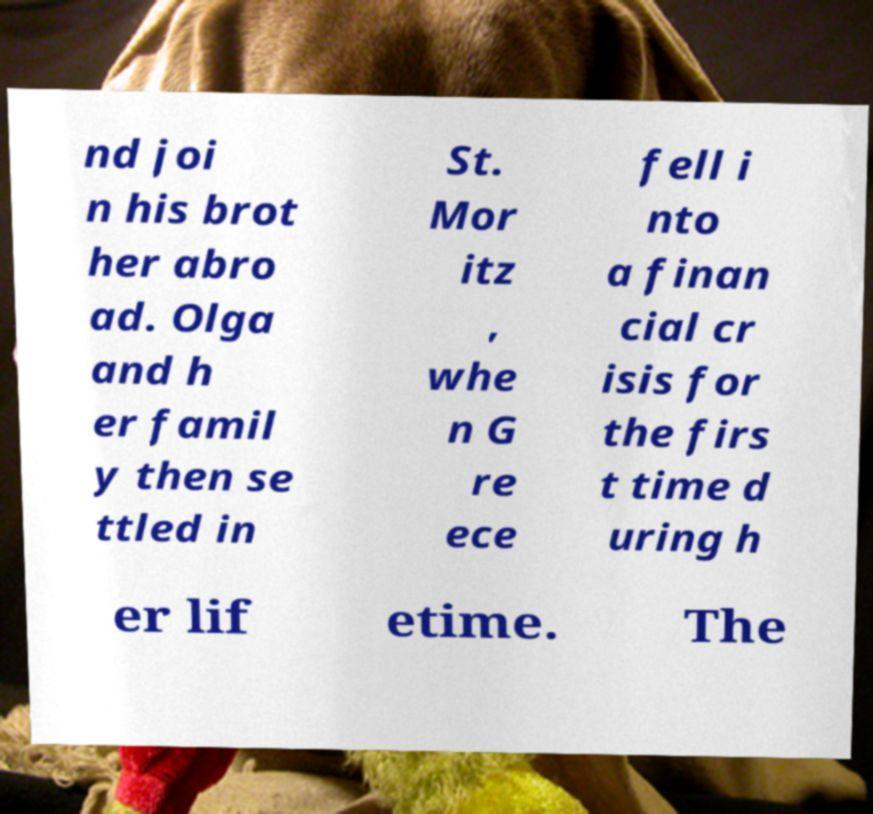What messages or text are displayed in this image? I need them in a readable, typed format. nd joi n his brot her abro ad. Olga and h er famil y then se ttled in St. Mor itz , whe n G re ece fell i nto a finan cial cr isis for the firs t time d uring h er lif etime. The 